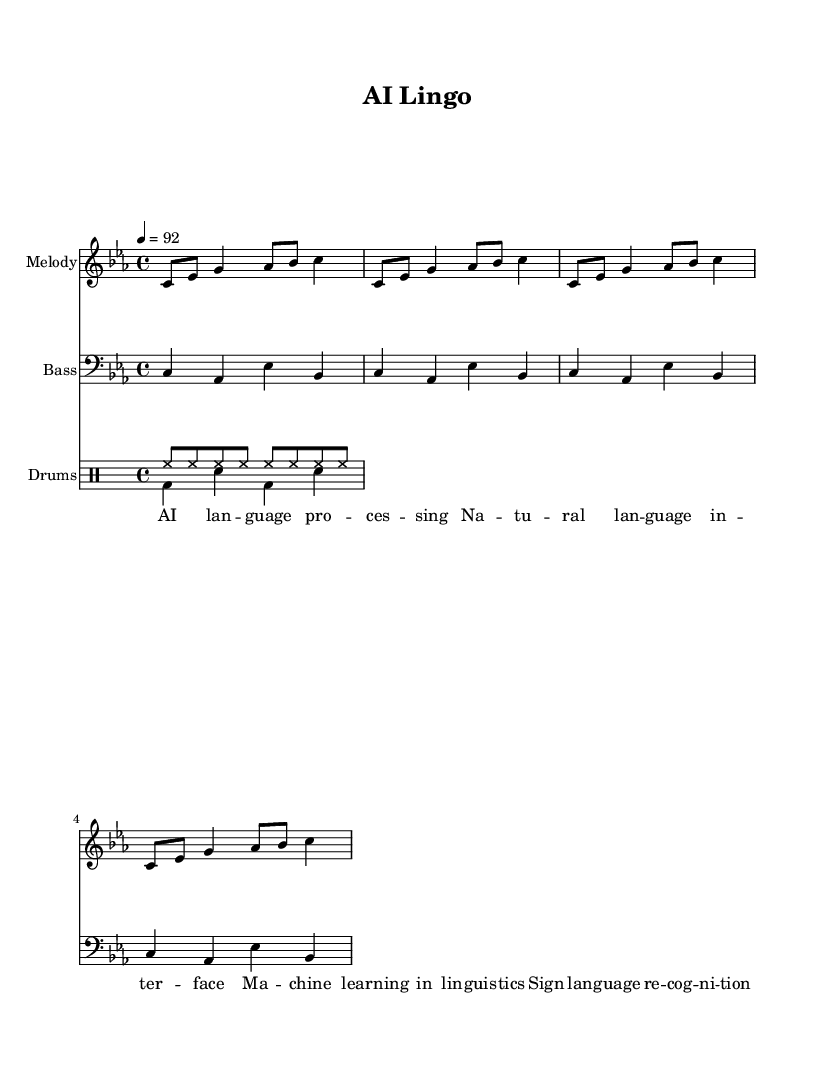What is the key signature of this music? The key signature is C minor, which has three flats. You can identify the key signature by looking at the beginning of the staff lines where the flats are placed.
Answer: C minor What is the time signature of this music? The time signature is 4/4, which indicates there are four beats in each measure, and each beat is a quarter note. This information is displayed at the beginning of the score, represented by the numbers 4 over 4.
Answer: 4/4 What is the tempo of this music? The tempo is marked at 92 beats per minute. This is specified at the beginning of the score, indicating how fast the music should be played.
Answer: 92 How many measures are in the melody? There are eight measures in the melody. By counting the grouping of notes and rests presented in the melody line, each set of notes separated by bar lines represents a measure.
Answer: Eight What is the primary focus of the lyrics in this rap? The primary focus of the lyrics is on AI and language processing. Analyzing the words from the lyric section reveals themes related to natural language, machine learning, and sign language recognition.
Answer: AI language processing What type of drum pattern is used for the hi-hats? The hi-hat pattern is a steady eighth-note pattern. In the drum notation, each "hh" represents a hi-hat strike occurring on every eighth note, resulting in a continuous rhythm throughout the measures.
Answer: Eighth-note pattern What genre of music does this piece represent? This piece represents the genre of rap. The lyrics and rhythmic structure, along with the use of percussion and emphasis on wordplay, are characteristic elements found within rap music.
Answer: Rap 